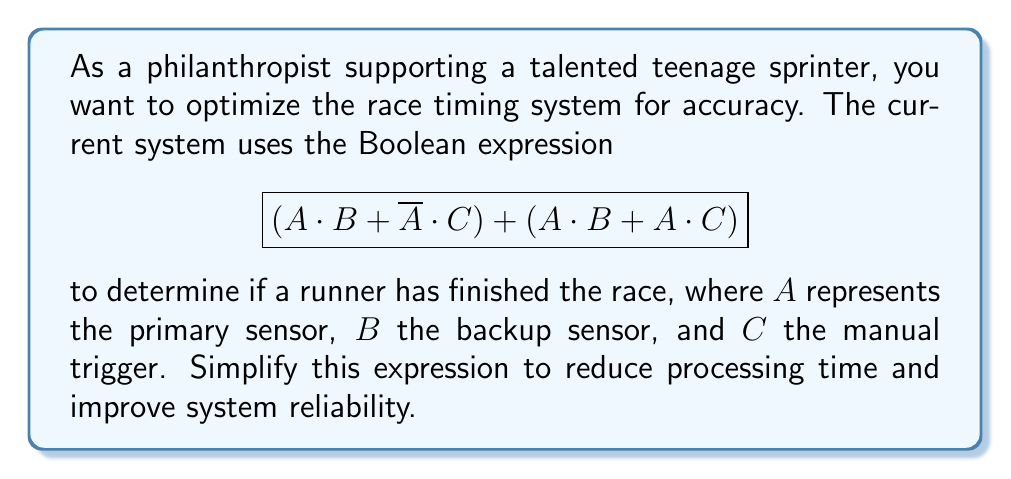Could you help me with this problem? Let's simplify the expression step by step:

1) First, let's distribute $A$ in the second term:
   $$(A \cdot B + \overline{A} \cdot C) + (A \cdot B + A \cdot C)$$

2) Now we can combine like terms:
   $$(A \cdot B + \overline{A} \cdot C) + A \cdot B + A \cdot C$$

3) Rearranging the terms:
   $$A \cdot B + A \cdot B + A \cdot C + \overline{A} \cdot C$$

4) Combining the duplicate $A \cdot B$ terms:
   $$A \cdot B + A \cdot C + \overline{A} \cdot C$$

5) We can factor out $C$ from the last two terms:
   $$A \cdot B + C \cdot (A + \overline{A})$$

6) The term $(A + \overline{A})$ is always true (equals 1 in Boolean algebra), so we can simplify:
   $$A \cdot B + C$$

This final expression $A \cdot B + C$ represents that the race is finished if either both the primary and backup sensors are triggered $(A \cdot B)$, or if the manual trigger is activated $(C)$.
Answer: $$A \cdot B + C$$ 